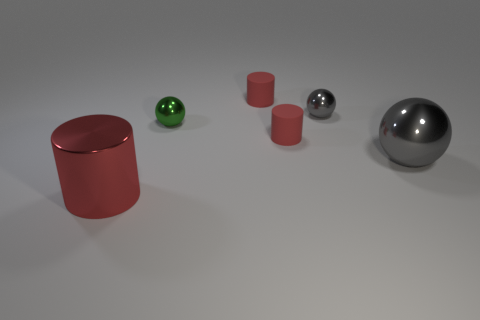Subtract all red cylinders. How many were subtracted if there are1red cylinders left? 2 Subtract all small matte cylinders. How many cylinders are left? 1 Subtract 1 cylinders. How many cylinders are left? 2 Subtract all green cylinders. How many gray spheres are left? 2 Subtract all red matte balls. Subtract all big gray metallic spheres. How many objects are left? 5 Add 6 big red metal objects. How many big red metal objects are left? 7 Add 5 large gray balls. How many large gray balls exist? 6 Add 4 small gray matte balls. How many objects exist? 10 Subtract all gray spheres. How many spheres are left? 1 Subtract 0 yellow blocks. How many objects are left? 6 